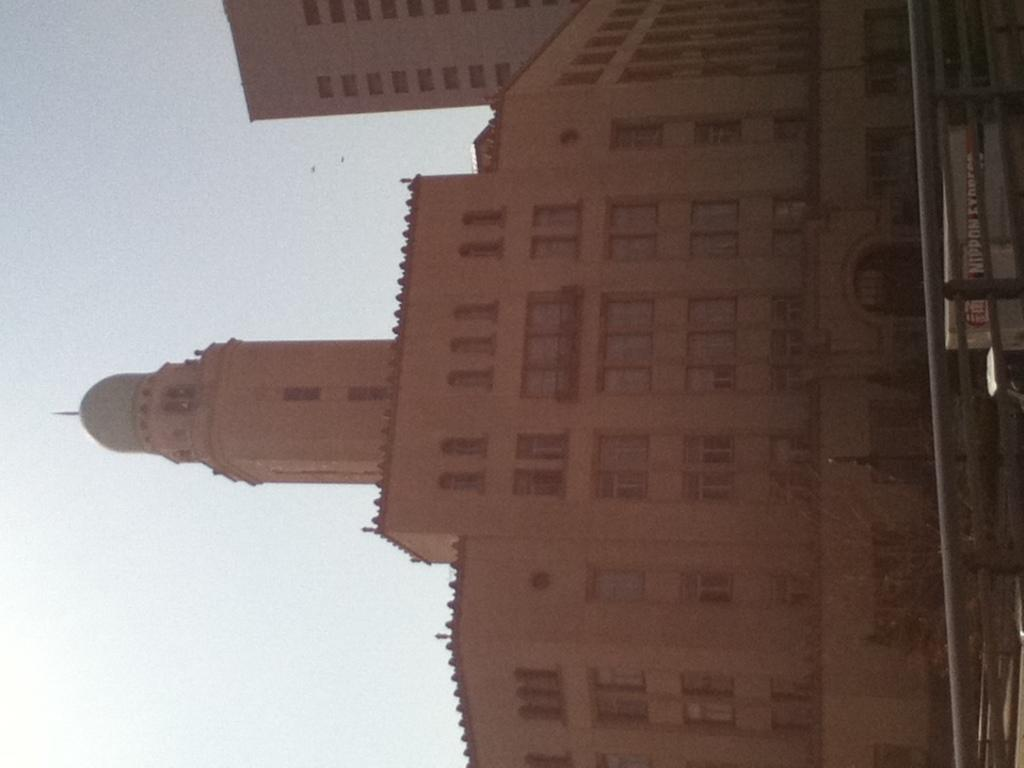What type of structures are present in the image? There are two big buildings in the image. What can be seen on the surface in the image? There are objects on the surface in the image. What type of barrier is present in the image? There is a fence in the image. What are the tall, thin structures in the image? There are poles in the image. What is written or displayed on a board in the image? There is a board with text in the image. What is visible at the top of the image? The sky is visible at the top of the image. How does the steam escape from the buildings in the image? There is no steam present in the image; it only features two big buildings, objects on the surface, a fence, poles, a board with text, and the sky. 